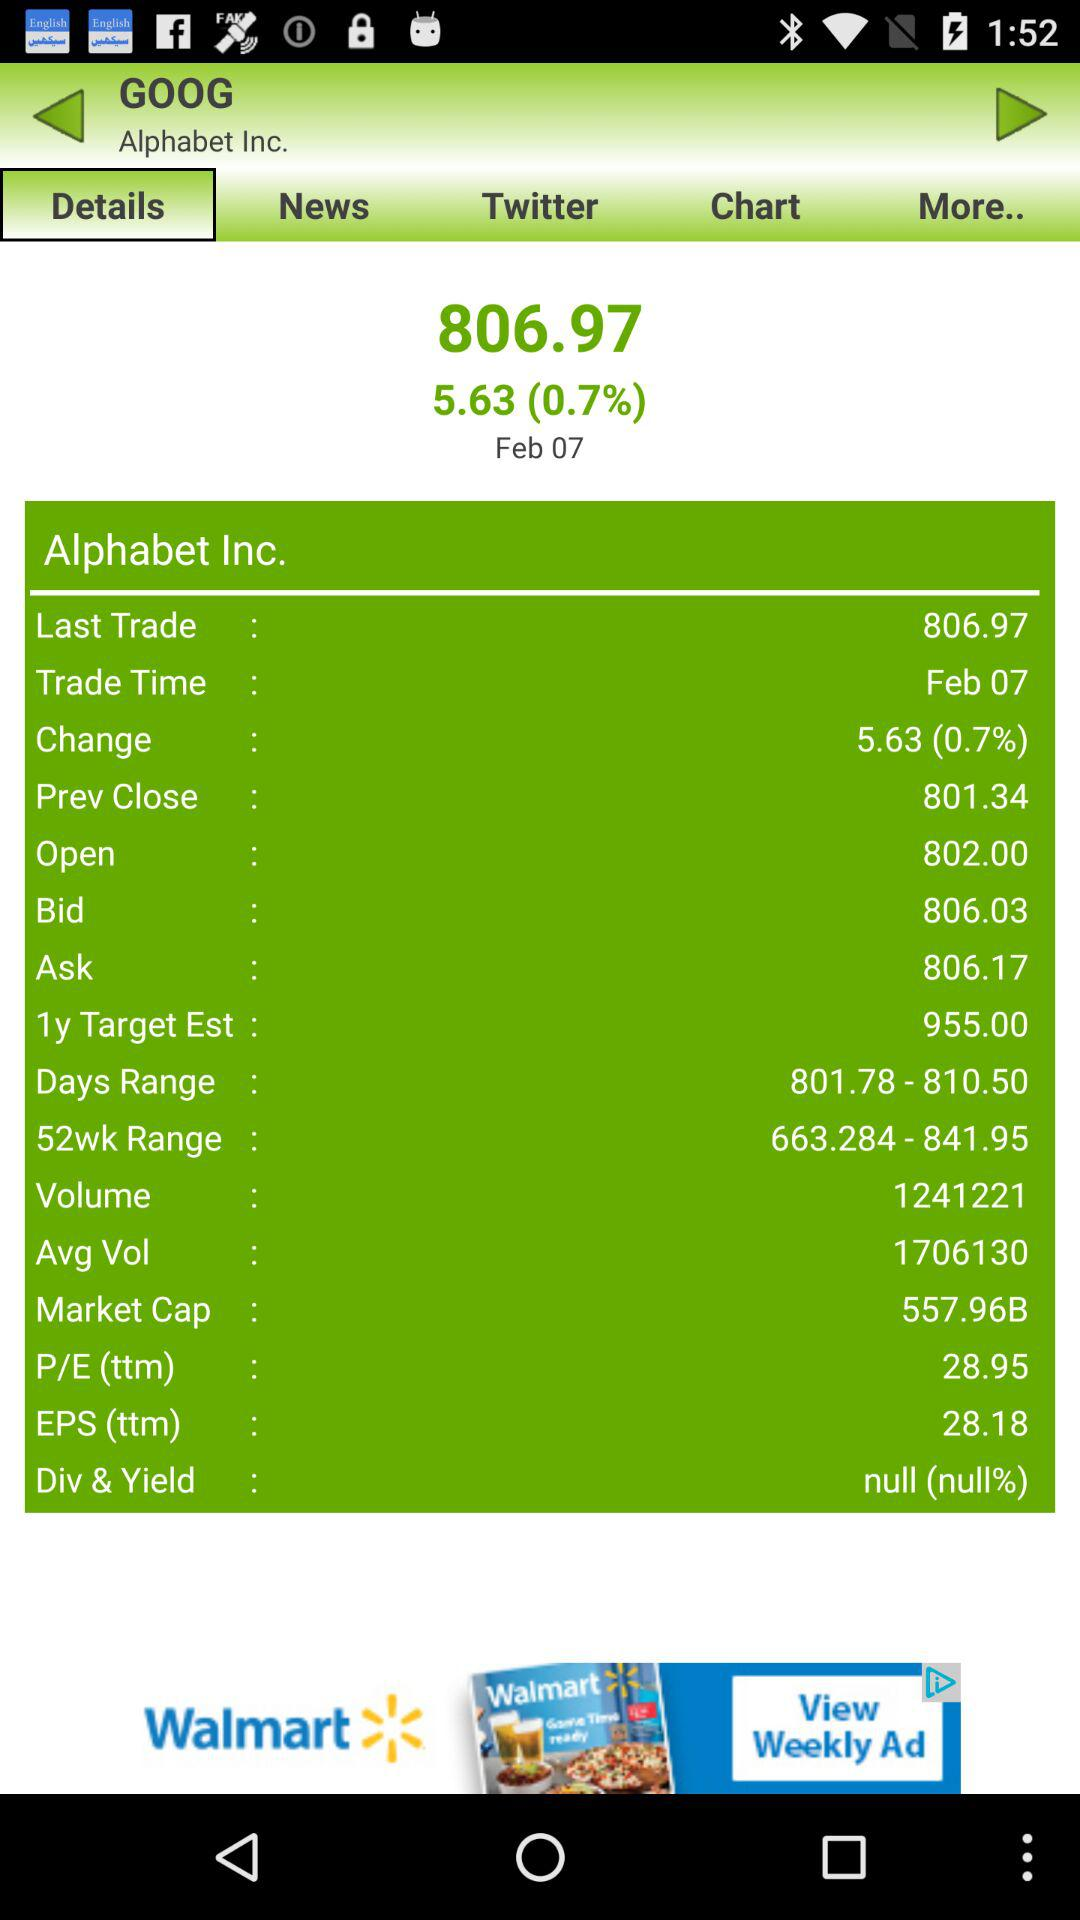What is the "Trade Time" of "Alphabet Inc."? The "Trade Time" of "Alphabet Inc." is February 7. 